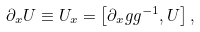Convert formula to latex. <formula><loc_0><loc_0><loc_500><loc_500>\partial _ { x } U \equiv U _ { x } = \left [ \partial _ { x } g g ^ { - 1 } , U \right ] ,</formula> 